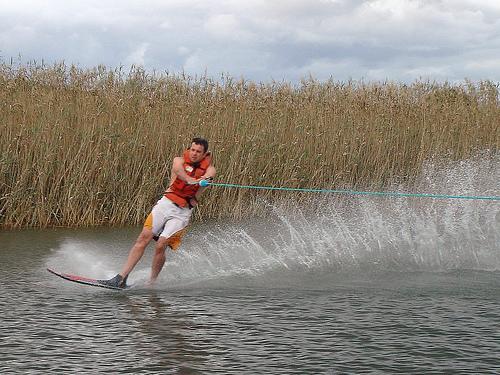What is pulling the man?
Write a very short answer. Boat. What type of sport is this man doing?
Keep it brief. Water skiing. What body of water is the person in?
Keep it brief. Lake. 